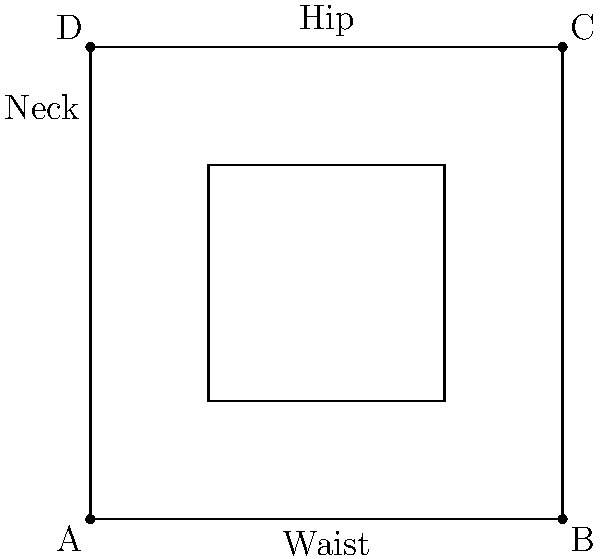As a fitness influencer who emphasizes the importance of body composition, you're explaining how to estimate body fat percentage using the U.S. Navy method. Using the body shape diagram provided, which measurements are needed to calculate body fat percentage for men, and what is the formula used? To calculate body fat percentage using the U.S. Navy method for men, we need to follow these steps:

1. Identify the required measurements:
   a) Neck circumference
   b) Waist circumference
   c) Height

2. The U.S. Navy formula for men is:

   $$ \text{Body Fat \%} = 86.010 \times \log_{10}(\text{Waist} - \text{Neck}) - 70.041 \times \log_{10}(\text{Height}) + 36.76 $$

   Where all measurements are in inches.

3. In the diagram:
   - The neck measurement is taken at the narrowest point, typically just below the larynx.
   - The waist measurement is taken at the navel level, around the largest part of the abdomen.
   - Height is not shown in the diagram but is a crucial measurement for the formula.

4. It's important to note that while this method is widely used, it's an estimation and may not be as accurate as other methods like DEXA scans or hydrostatic weighing.

5. As a fitness influencer, you should emphasize that this method is a good starting point for tracking progress, but individual results may vary.
Answer: Neck, waist, height; $86.010 \times \log_{10}(\text{Waist} - \text{Neck}) - 70.041 \times \log_{10}(\text{Height}) + 36.76$ 